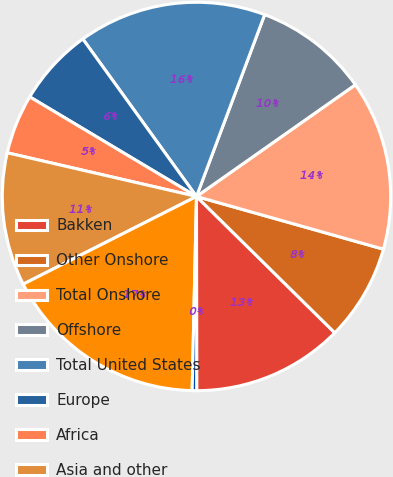Convert chart. <chart><loc_0><loc_0><loc_500><loc_500><pie_chart><fcel>Bakken<fcel>Other Onshore<fcel>Total Onshore<fcel>Offshore<fcel>Total United States<fcel>Europe<fcel>Africa<fcel>Asia and other<fcel>E&P - Capital and Exploratory<fcel>United States<nl><fcel>12.6%<fcel>8.01%<fcel>14.13%<fcel>9.54%<fcel>15.66%<fcel>6.48%<fcel>4.96%<fcel>11.07%<fcel>17.19%<fcel>0.37%<nl></chart> 